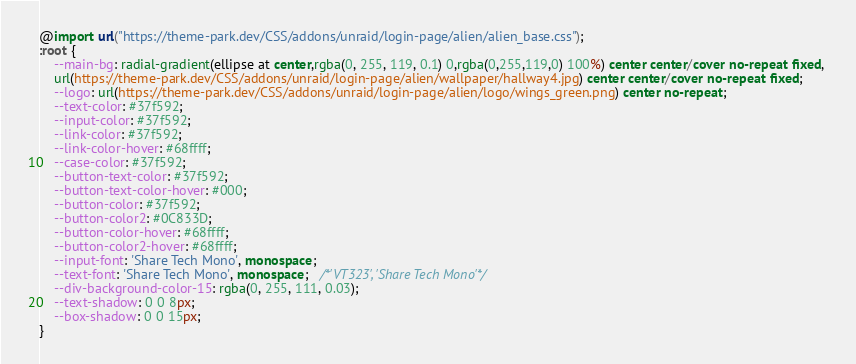Convert code to text. <code><loc_0><loc_0><loc_500><loc_500><_CSS_>@import url("https://theme-park.dev/CSS/addons/unraid/login-page/alien/alien_base.css");
:root {
    --main-bg: radial-gradient(ellipse at center,rgba(0, 255, 119, 0.1) 0,rgba(0,255,119,0) 100%) center center/cover no-repeat fixed, 
    url(https://theme-park.dev/CSS/addons/unraid/login-page/alien/wallpaper/hallway4.jpg) center center/cover no-repeat fixed;
    --logo: url(https://theme-park.dev/CSS/addons/unraid/login-page/alien/logo/wings_green.png) center no-repeat;
    --text-color: #37f592;
    --input-color: #37f592;
    --link-color: #37f592;
    --link-color-hover: #68ffff;
    --case-color: #37f592;
    --button-text-color: #37f592;
    --button-text-color-hover: #000;
    --button-color: #37f592;
    --button-color2: #0C833D;
    --button-color-hover: #68ffff;
    --button-color2-hover: #68ffff;
    --input-font: 'Share Tech Mono', monospace;
    --text-font: 'Share Tech Mono', monospace;   /*'VT323', 'Share Tech Mono'*/
    --div-background-color-15: rgba(0, 255, 111, 0.03);
    --text-shadow: 0 0 8px;
    --box-shadow: 0 0 15px;
}</code> 